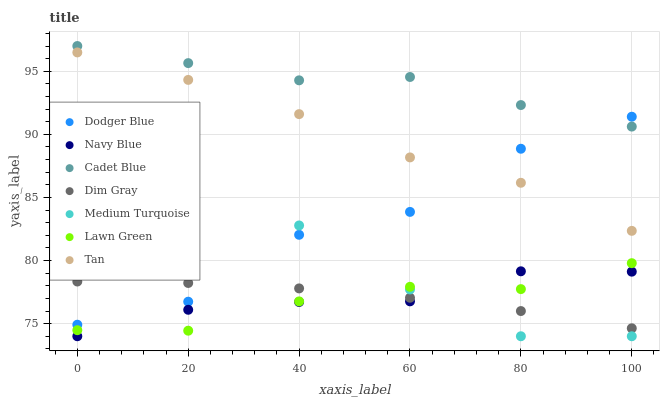Does Lawn Green have the minimum area under the curve?
Answer yes or no. Yes. Does Cadet Blue have the maximum area under the curve?
Answer yes or no. Yes. Does Dim Gray have the minimum area under the curve?
Answer yes or no. No. Does Dim Gray have the maximum area under the curve?
Answer yes or no. No. Is Dim Gray the smoothest?
Answer yes or no. Yes. Is Dodger Blue the roughest?
Answer yes or no. Yes. Is Navy Blue the smoothest?
Answer yes or no. No. Is Navy Blue the roughest?
Answer yes or no. No. Does Navy Blue have the lowest value?
Answer yes or no. Yes. Does Dim Gray have the lowest value?
Answer yes or no. No. Does Cadet Blue have the highest value?
Answer yes or no. Yes. Does Navy Blue have the highest value?
Answer yes or no. No. Is Lawn Green less than Dodger Blue?
Answer yes or no. Yes. Is Dodger Blue greater than Lawn Green?
Answer yes or no. Yes. Does Dodger Blue intersect Tan?
Answer yes or no. Yes. Is Dodger Blue less than Tan?
Answer yes or no. No. Is Dodger Blue greater than Tan?
Answer yes or no. No. Does Lawn Green intersect Dodger Blue?
Answer yes or no. No. 